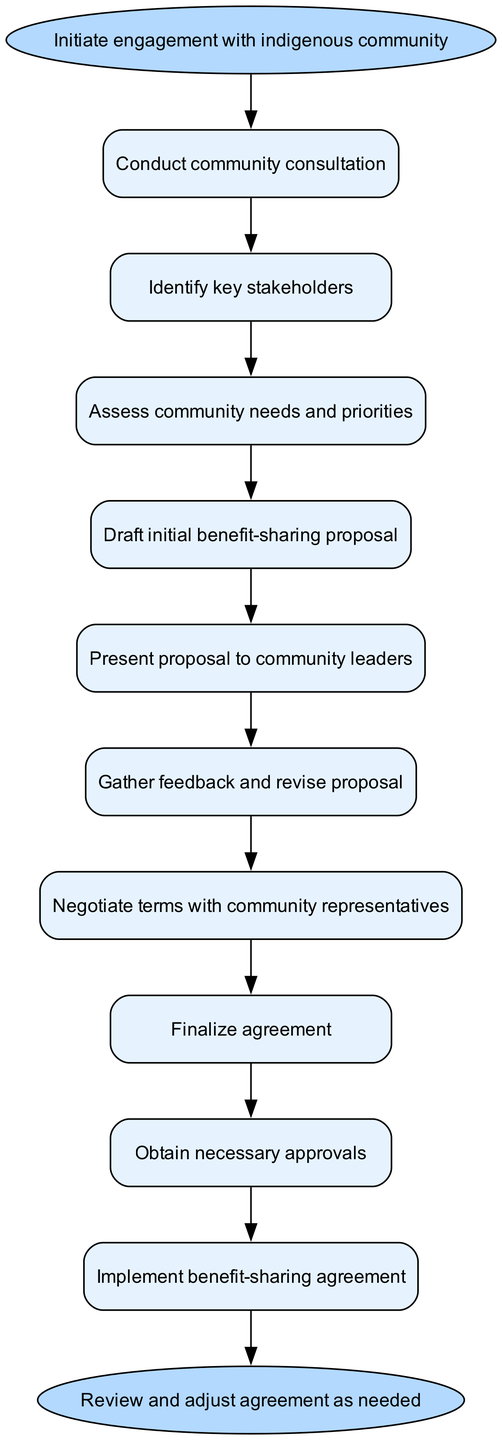What is the first step in the process? The diagram indicates that the first step in the process is labeled as "Initiate engagement with indigenous community". This is the starting point before any other actions are taken.
Answer: Initiate engagement with indigenous community How many steps are there in total? By counting the number of individual steps listed in the diagram, there are a total of ten steps in the process. Each step represents a distinct action that contributes to the overall goal.
Answer: 10 What comes after "Gather feedback and revise proposal"? The arrow in the diagram shows that after "Gather feedback and revise proposal", the next step is "Negotiate terms with community representatives". This implies that negotiation occurs following the feedback process.
Answer: Negotiate terms with community representatives What is the last step before implementation? The diagram shows that before the implementation occurs, the last step to take is "Obtain necessary approvals". This step is crucial as it ensures that all required permissions are secured before moving forward.
Answer: Obtain necessary approvals Which step occurs directly after "Draft initial benefit-sharing proposal"? The flow indicates that immediately after "Draft initial benefit-sharing proposal", the next step is "Present proposal to community leaders". This shows a direct progression from drafting to presenting.
Answer: Present proposal to community leaders What is the relationship between "Assess community needs and priorities" and "Identify key stakeholders"? The diagram demonstrates that "Identify key stakeholders" follows "Conduct community consultation", and "Assess community needs and priorities" follows "Identify key stakeholders". Therefore, the relationship is that identifying stakeholders is a necessary precursor to assessing community needs.
Answer: Sequential How many approvals are necessary before implementing the benefit-sharing agreement? According to the flow chart, "Obtain necessary approvals" is a single step in the process that must be completed before implementation. Therefore, it implies that necessary approvals must occur, but the chart does not specify a number or detail the types of approvals.
Answer: One approval What is the goal of the process? The overall goal of this flow chart process is to develop and implement benefit-sharing agreements. This is inferred from the context of the steps depicted leading to the final actions and outcomes.
Answer: Benefit-sharing agreement What happens if the agreement needs changes after implementation? According to the final step of the flow, the phrase "Review and adjust agreement as needed" suggests that there is a mechanism to revisit and modify the agreement based on ongoing evaluation.
Answer: Review and adjust agreement as needed 